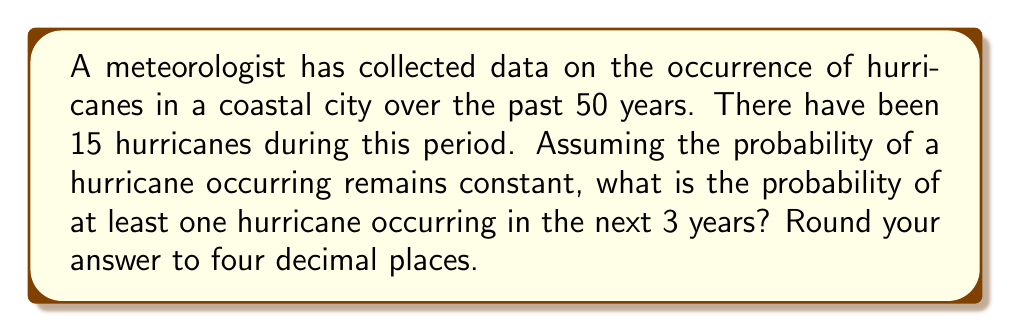Could you help me with this problem? Let's approach this step-by-step:

1) First, we need to calculate the probability of a hurricane occurring in a single year:
   $p = \frac{\text{Number of hurricanes}}{\text{Number of years}} = \frac{15}{50} = 0.3$

2) Now, we want to find the probability of at least one hurricane in 3 years. It's often easier to calculate the probability of the complement event (no hurricanes in 3 years) and subtract from 1.

3) The probability of no hurricane in a single year is:
   $1 - p = 1 - 0.3 = 0.7$

4) For no hurricanes in 3 years, this needs to happen 3 times in a row. Assuming independence, we multiply these probabilities:
   $P(\text{no hurricanes in 3 years}) = (0.7)^3 = 0.343$

5) Therefore, the probability of at least one hurricane in 3 years is:
   $P(\text{at least one hurricane in 3 years}) = 1 - P(\text{no hurricanes in 3 years})$
   $= 1 - 0.343 = 0.657$

6) Rounding to four decimal places:
   $0.657 \approx 0.6570$
Answer: $0.6570$ 